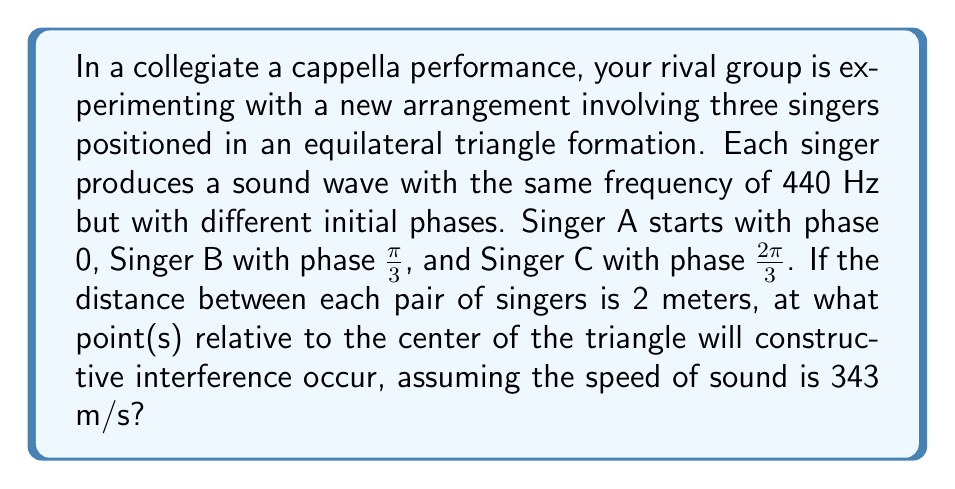Give your solution to this math problem. Let's approach this step-by-step:

1) First, we need to calculate the wavelength of the sound:
   $\lambda = \frac{v}{f} = \frac{343 \text{ m/s}}{440 \text{ Hz}} = 0.78 \text{ m}$

2) The phase difference due to path difference is given by:
   $\Delta \phi = \frac{2\pi}{\lambda} \Delta r$

3) For constructive interference, we need the total phase difference (including initial phase differences) to be a multiple of $2\pi$:
   $\Delta \phi_{\text{total}} = \Delta \phi_{\text{path}} + \Delta \phi_{\text{initial}} = 2\pi n$, where $n$ is an integer

4) Let's define the coordinates: center of the triangle is (0,0), Singer A at $(-\frac{\sqrt{3}}{3},1)$, B at $(\frac{\sqrt{3}}{3},1)$, and C at $(0,-1)$

5) For a point $(x,y)$, the path differences from the center are:
   $\Delta r_A = \sqrt{(x+\frac{\sqrt{3}}{3})^2 + (y-1)^2} - \frac{\sqrt{3}}{3}$
   $\Delta r_B = \sqrt{(x-\frac{\sqrt{3}}{3})^2 + (y-1)^2} - \frac{\sqrt{3}}{3}$
   $\Delta r_C = \sqrt{x^2 + (y+1)^2} - 1$

6) The total phase differences are:
   $\Delta \phi_{\text{total},AB} = \frac{2\pi}{\lambda}(\Delta r_B - \Delta r_A) + \frac{\pi}{3} = 2\pi n$
   $\Delta \phi_{\text{total},BC} = \frac{2\pi}{\lambda}(\Delta r_C - \Delta r_B) + \frac{\pi}{3} = 2\pi m$
   $\Delta \phi_{\text{total},CA} = \frac{2\pi}{\lambda}(\Delta r_A - \Delta r_C) + \frac{\pi}{3} = 2\pi k$

7) Solving these equations simultaneously gives us the points of constructive interference. Due to symmetry, we can deduce that one solution will be at the center (0,0), as all path differences are zero there and the initial phase differences sum to $2\pi$.

8) Other points of constructive interference will form a pattern around the center, but their exact locations depend on the specific integer values of n, m, and k.
Answer: (0,0) and symmetric points around the center forming a pattern determined by the wavelength and initial phase differences. 